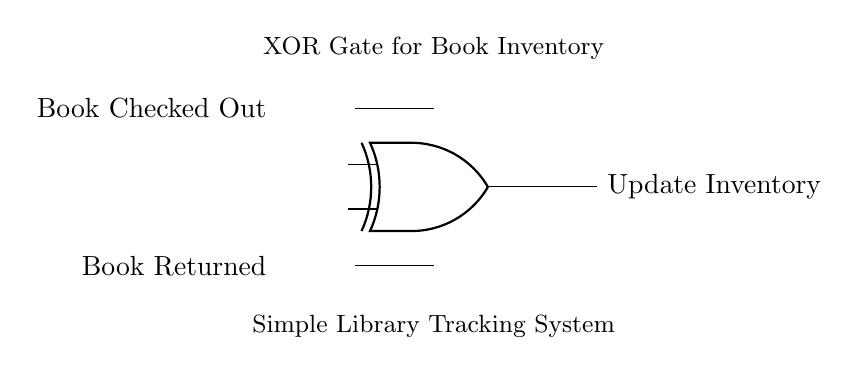What type of logic gate is shown in the circuit? The circuit clearly depicts an XOR gate, which is identified by its unique symbol in the diagram. It has two inputs and one output.
Answer: XOR gate How many inputs does the XOR gate have? The diagram shows two lines entering the XOR gate, which represent the inputs for the gate.
Answer: Two inputs What is the function of the output in this circuit? The output of the XOR gate, labeled 'Update Inventory', indicates a change in the system's state based on the inputs. The XOR gate outputs high when exactly one of its inputs is high.
Answer: Update Inventory Describe the significance of the 'Book Checked Out' and 'Book Returned' inputs. The 'Book Checked Out' input indicates when a book is taken out, while the 'Book Returned' signal indicates when a book is put back. The XOR gate processes these inputs to determine if the inventory should update.
Answer: Track book status What condition causes the inventory to update? The XOR gate's output will be activated, updating the inventory when one and only one of the inputs ("Book Checked Out" or "Book Returned") is true. If both are high or both are low, the output remains low.
Answer: One input is true Why is an XOR gate used instead of an AND or OR gate in this circuit? The XOR gate is specifically chosen because it allows the output to reflect a state change when only one of its inputs is active. This behavior is essential for tracking book check-outs and returns distinctly.
Answer: To detect single status changes What would be the output if both inputs are low? If both inputs ('Book Checked Out' and 'Book Returned') are low, the XOR gate will not activate, resulting in a low output. The output signal will indicate that no inventory update is needed.
Answer: Low output 